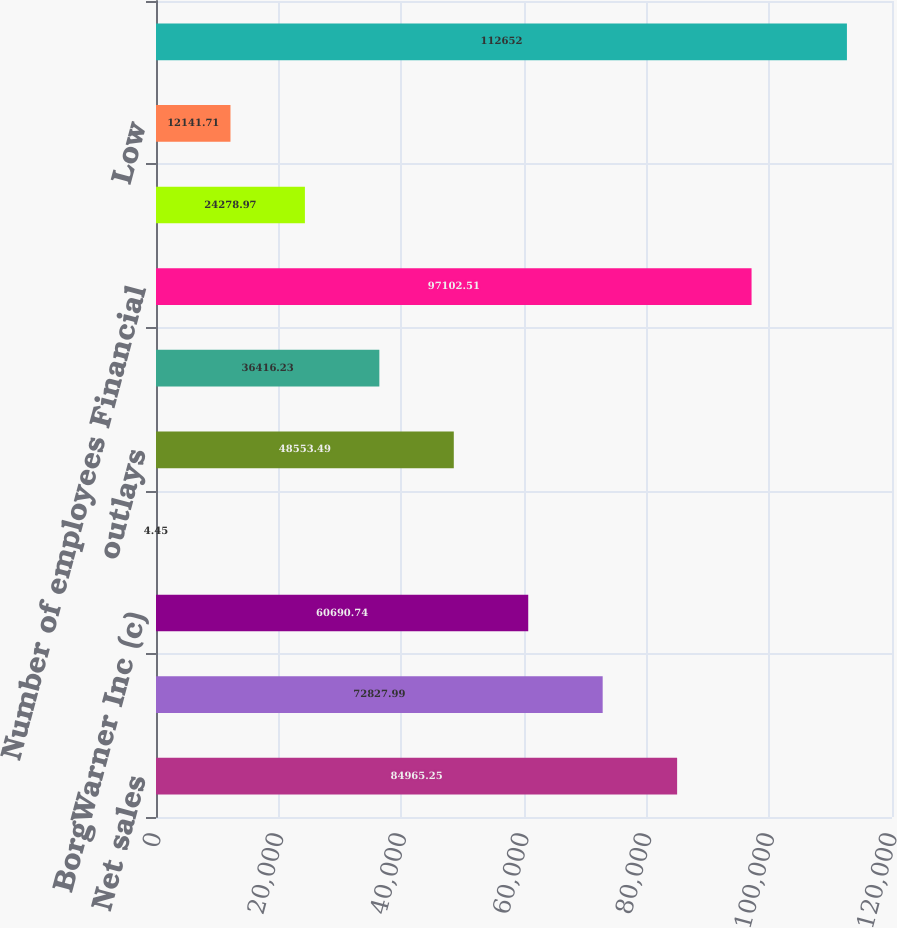<chart> <loc_0><loc_0><loc_500><loc_500><bar_chart><fcel>Net sales<fcel>Operating income (c) Net<fcel>BorgWarner Inc (c)<fcel>Earnings (loss) per share -<fcel>outlays<fcel>Depreciation and tooling<fcel>Number of employees Financial<fcel>High<fcel>Low<fcel>Basic<nl><fcel>84965.2<fcel>72828<fcel>60690.7<fcel>4.45<fcel>48553.5<fcel>36416.2<fcel>97102.5<fcel>24279<fcel>12141.7<fcel>112652<nl></chart> 